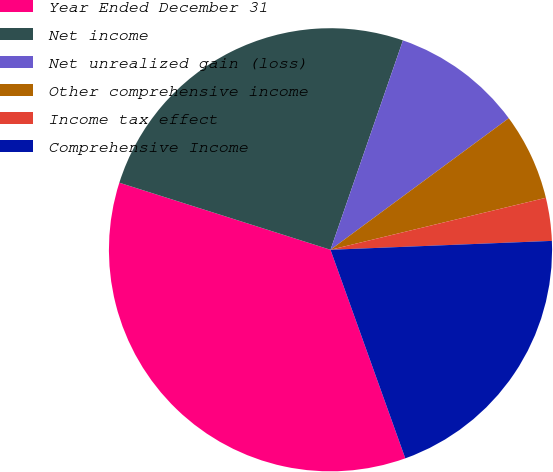<chart> <loc_0><loc_0><loc_500><loc_500><pie_chart><fcel>Year Ended December 31<fcel>Net income<fcel>Net unrealized gain (loss)<fcel>Other comprehensive income<fcel>Income tax effect<fcel>Comprehensive Income<nl><fcel>35.38%<fcel>25.41%<fcel>9.58%<fcel>6.35%<fcel>3.13%<fcel>20.16%<nl></chart> 